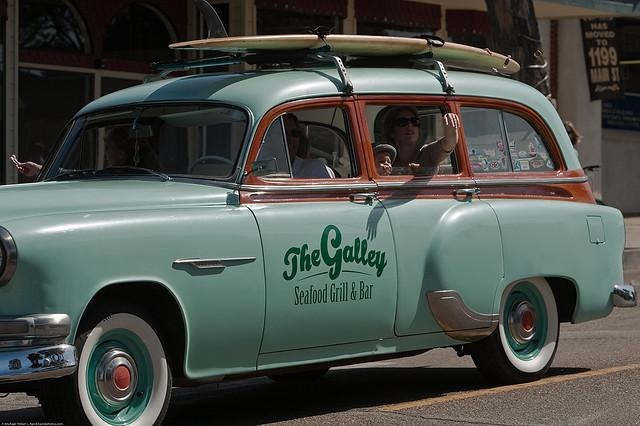Which one of these natural disasters might this car get caught in? Please explain your reasoning. earthquake. California has plenty of earthquakes and california is a surf state. 